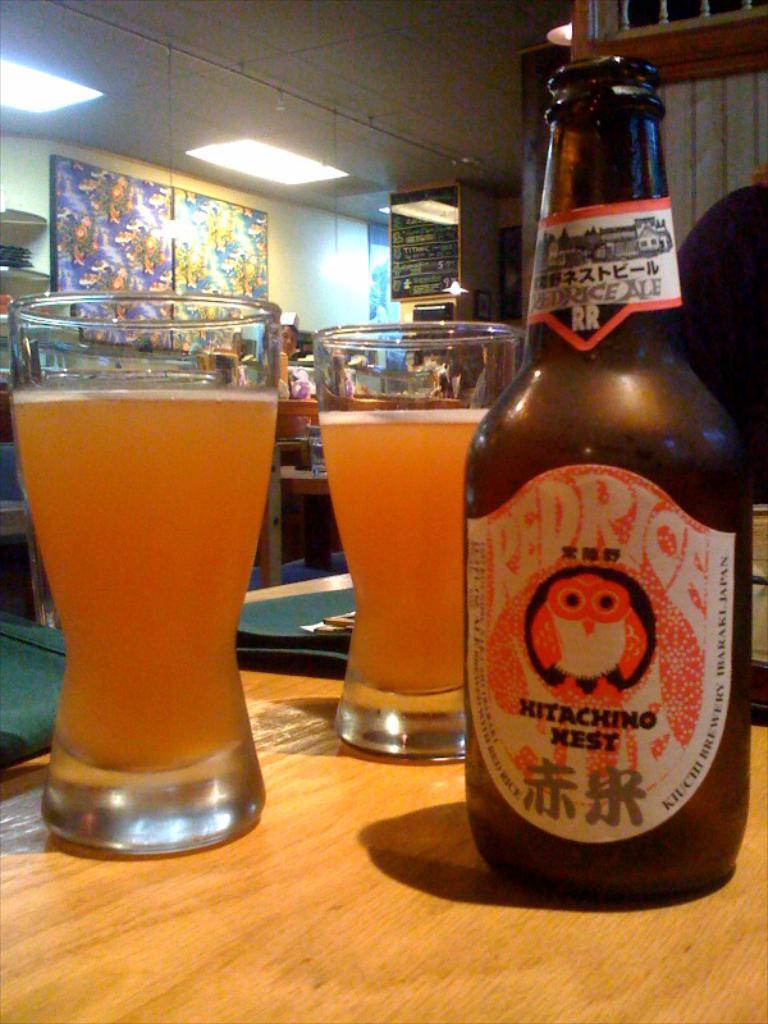What's this beer called?
Offer a terse response. Hitachino nest. What country is the beer from?
Provide a succinct answer. Japan. 